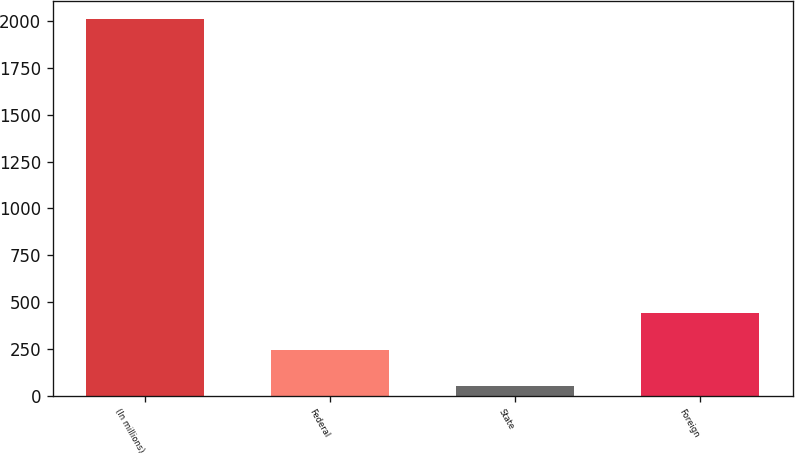Convert chart to OTSL. <chart><loc_0><loc_0><loc_500><loc_500><bar_chart><fcel>(In millions)<fcel>Federal<fcel>State<fcel>Foreign<nl><fcel>2010<fcel>246<fcel>50<fcel>442<nl></chart> 